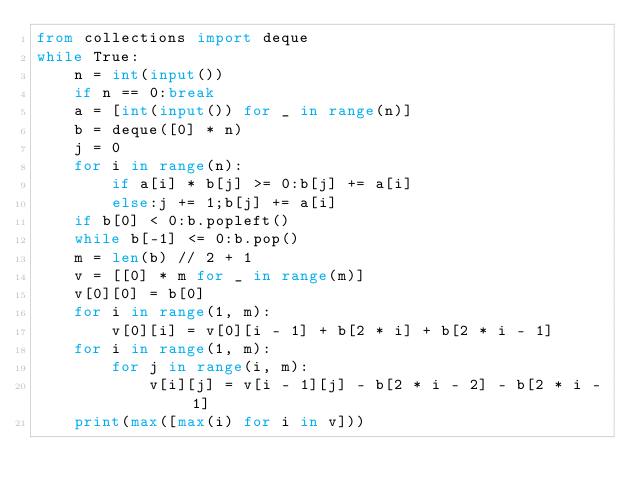Convert code to text. <code><loc_0><loc_0><loc_500><loc_500><_Python_>from collections import deque
while True:
    n = int(input())
    if n == 0:break
    a = [int(input()) for _ in range(n)]
    b = deque([0] * n)
    j = 0
    for i in range(n):
        if a[i] * b[j] >= 0:b[j] += a[i]
        else:j += 1;b[j] += a[i]
    if b[0] < 0:b.popleft()
    while b[-1] <= 0:b.pop()
    m = len(b) // 2 + 1
    v = [[0] * m for _ in range(m)]
    v[0][0] = b[0]
    for i in range(1, m):
        v[0][i] = v[0][i - 1] + b[2 * i] + b[2 * i - 1]
    for i in range(1, m):
        for j in range(i, m):
            v[i][j] = v[i - 1][j] - b[2 * i - 2] - b[2 * i - 1]
    print(max([max(i) for i in v]))
</code> 